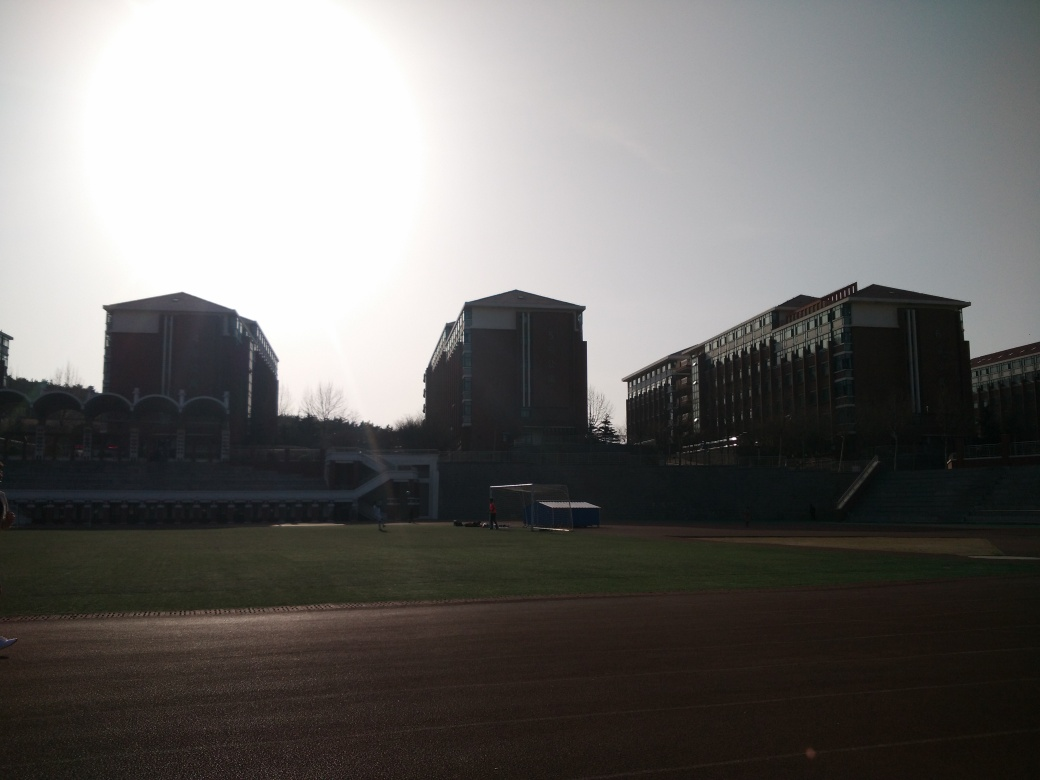Are there any quality issues with this image? Yes, there are a few quality issues with this image. The most apparent is the lens flare caused by the sunlight, resulting in a loss of contrast and visible details especially around the center. Additionally, the image is backlit which makes the buildings and foreground quite dark and lacking in visible detail. This might affect the ability to discern features or the scene accurately. There's also a slight tilt to the right, which could be corrected for better overall composition. 